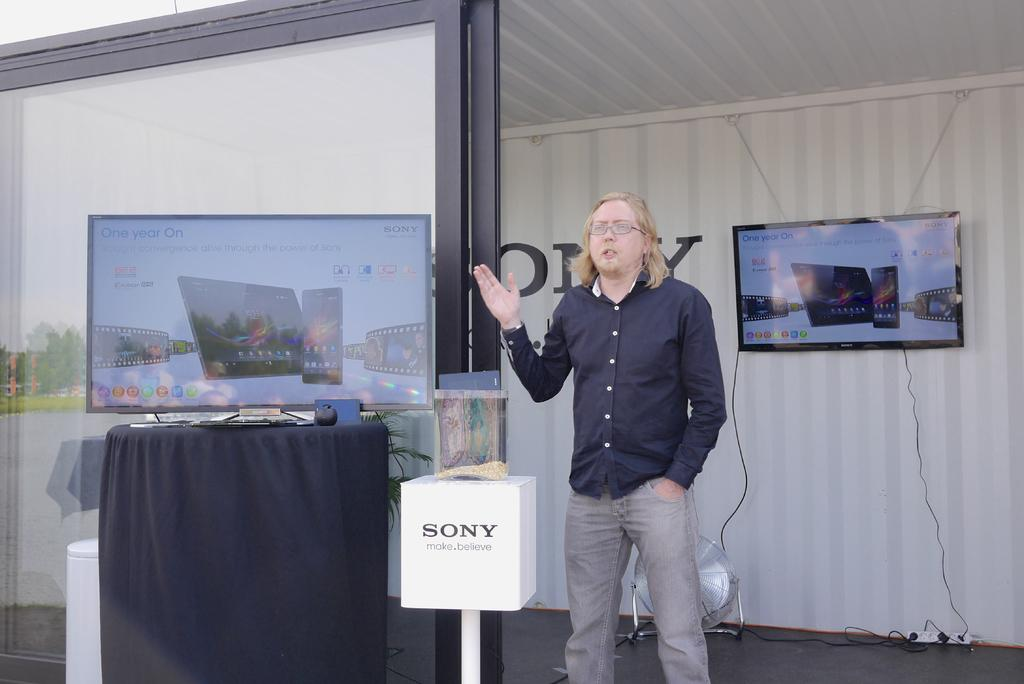<image>
Present a compact description of the photo's key features. A display table for Sony, with two televisions and a man presenting them. 